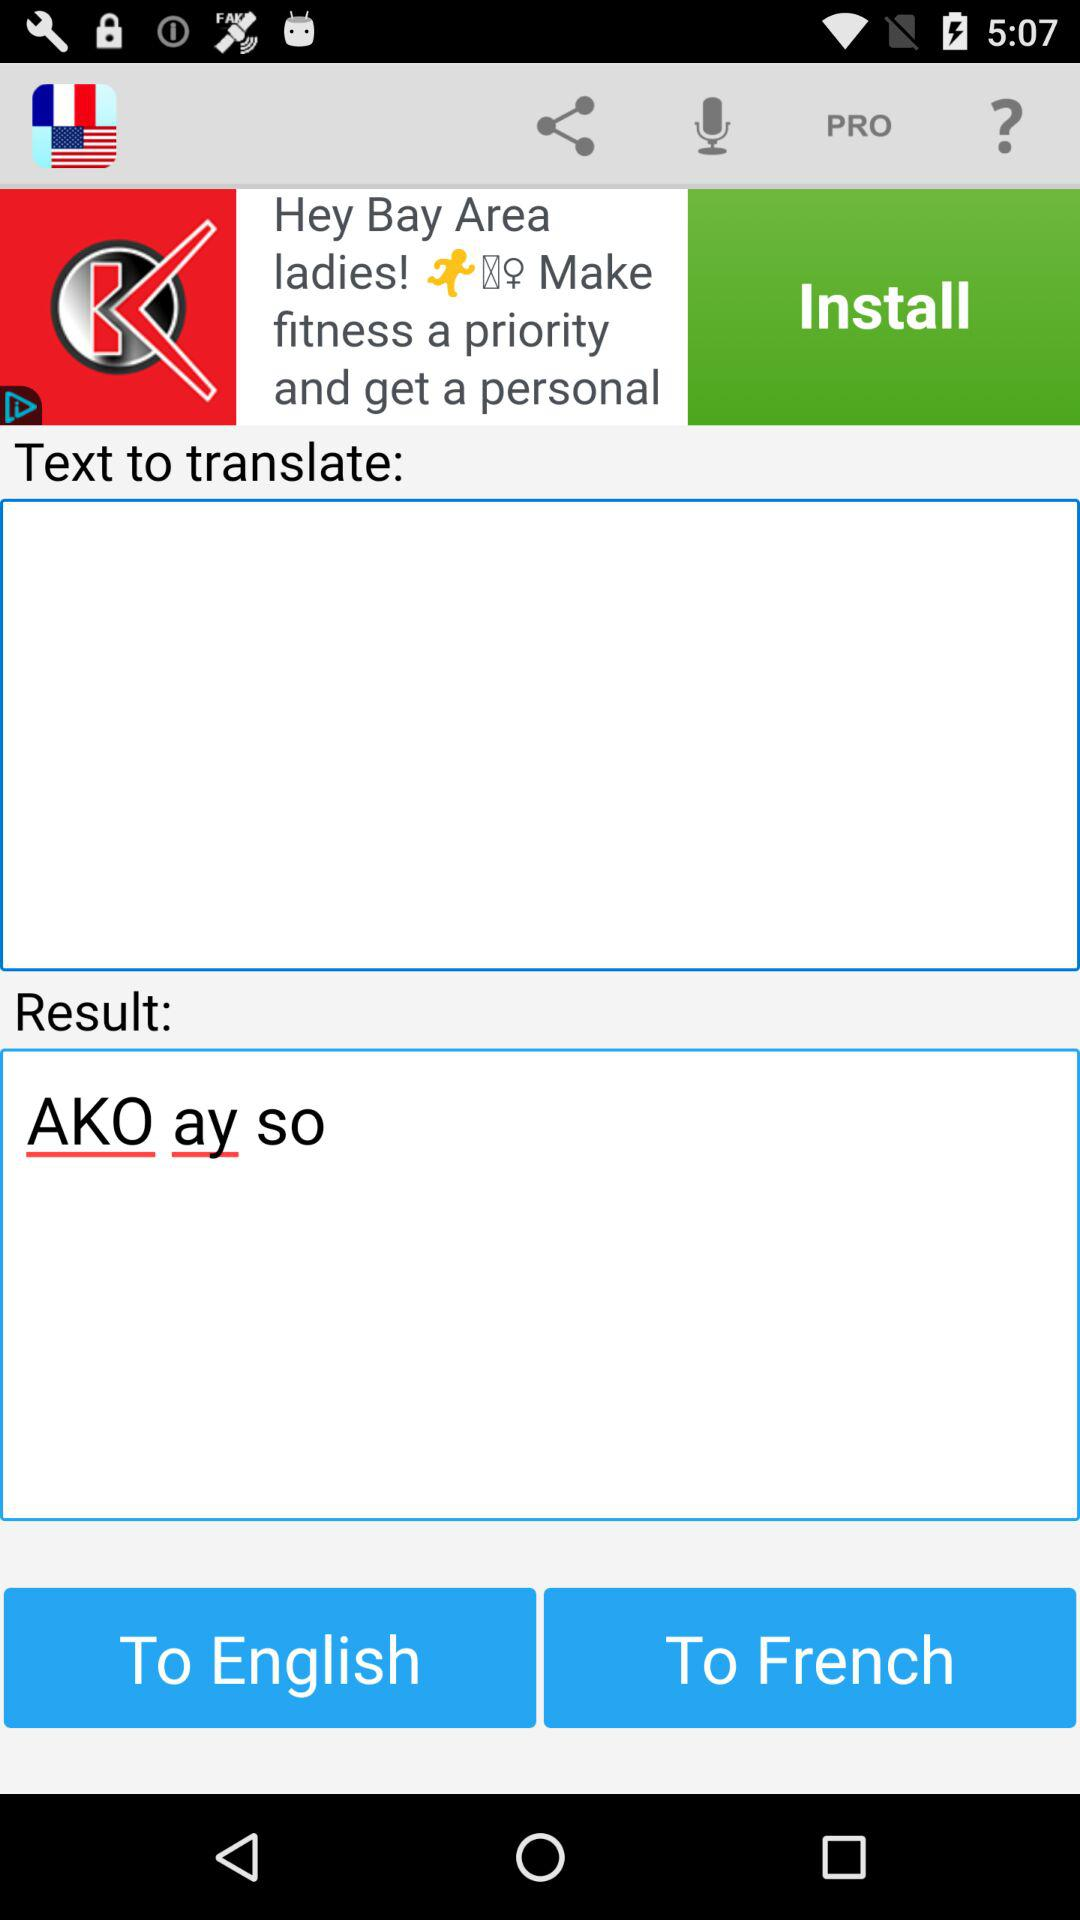What is the language translation paired with English in the current selection? The paired language is French. 